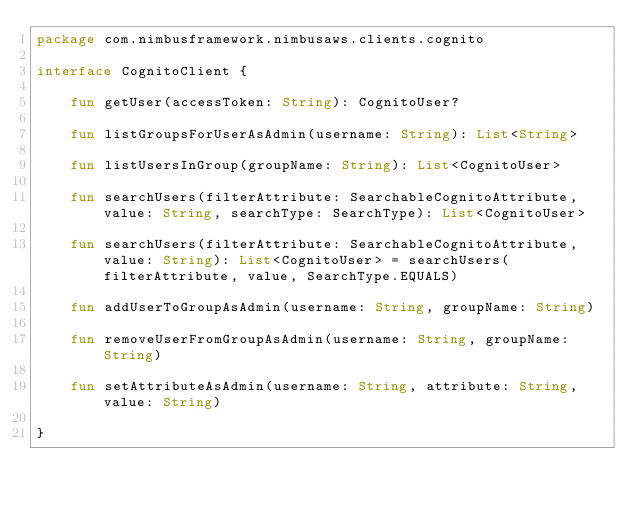<code> <loc_0><loc_0><loc_500><loc_500><_Kotlin_>package com.nimbusframework.nimbusaws.clients.cognito

interface CognitoClient {

    fun getUser(accessToken: String): CognitoUser?

    fun listGroupsForUserAsAdmin(username: String): List<String>

    fun listUsersInGroup(groupName: String): List<CognitoUser>

    fun searchUsers(filterAttribute: SearchableCognitoAttribute, value: String, searchType: SearchType): List<CognitoUser>

    fun searchUsers(filterAttribute: SearchableCognitoAttribute, value: String): List<CognitoUser> = searchUsers(filterAttribute, value, SearchType.EQUALS)

    fun addUserToGroupAsAdmin(username: String, groupName: String)

    fun removeUserFromGroupAsAdmin(username: String, groupName: String)

    fun setAttributeAsAdmin(username: String, attribute: String, value: String)

}
</code> 